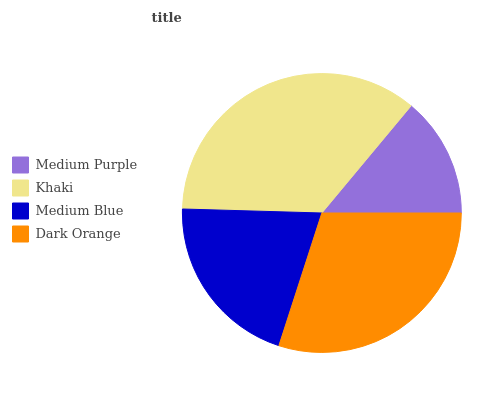Is Medium Purple the minimum?
Answer yes or no. Yes. Is Khaki the maximum?
Answer yes or no. Yes. Is Medium Blue the minimum?
Answer yes or no. No. Is Medium Blue the maximum?
Answer yes or no. No. Is Khaki greater than Medium Blue?
Answer yes or no. Yes. Is Medium Blue less than Khaki?
Answer yes or no. Yes. Is Medium Blue greater than Khaki?
Answer yes or no. No. Is Khaki less than Medium Blue?
Answer yes or no. No. Is Dark Orange the high median?
Answer yes or no. Yes. Is Medium Blue the low median?
Answer yes or no. Yes. Is Medium Blue the high median?
Answer yes or no. No. Is Medium Purple the low median?
Answer yes or no. No. 